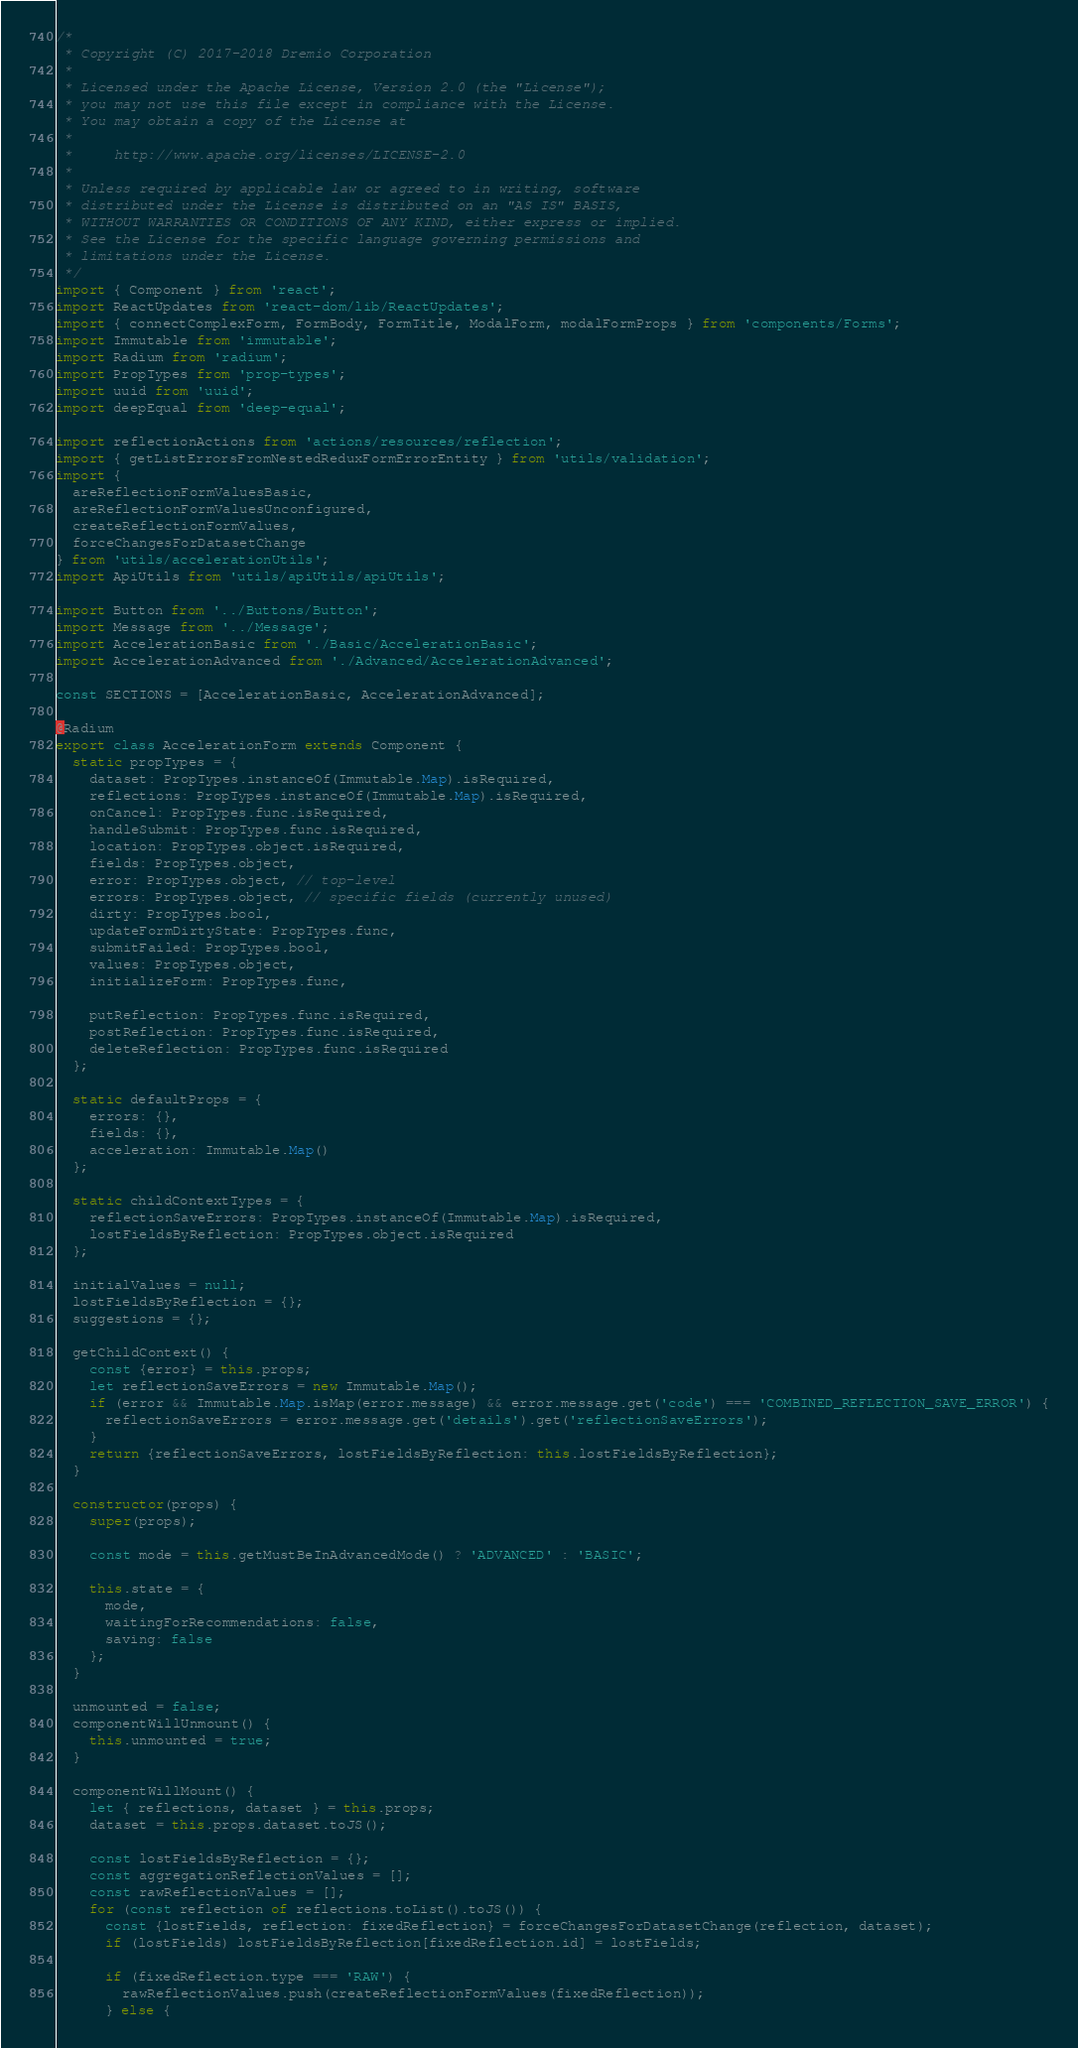Convert code to text. <code><loc_0><loc_0><loc_500><loc_500><_JavaScript_>/*
 * Copyright (C) 2017-2018 Dremio Corporation
 *
 * Licensed under the Apache License, Version 2.0 (the "License");
 * you may not use this file except in compliance with the License.
 * You may obtain a copy of the License at
 *
 *     http://www.apache.org/licenses/LICENSE-2.0
 *
 * Unless required by applicable law or agreed to in writing, software
 * distributed under the License is distributed on an "AS IS" BASIS,
 * WITHOUT WARRANTIES OR CONDITIONS OF ANY KIND, either express or implied.
 * See the License for the specific language governing permissions and
 * limitations under the License.
 */
import { Component } from 'react';
import ReactUpdates from 'react-dom/lib/ReactUpdates';
import { connectComplexForm, FormBody, FormTitle, ModalForm, modalFormProps } from 'components/Forms';
import Immutable from 'immutable';
import Radium from 'radium';
import PropTypes from 'prop-types';
import uuid from 'uuid';
import deepEqual from 'deep-equal';

import reflectionActions from 'actions/resources/reflection';
import { getListErrorsFromNestedReduxFormErrorEntity } from 'utils/validation';
import {
  areReflectionFormValuesBasic,
  areReflectionFormValuesUnconfigured,
  createReflectionFormValues,
  forceChangesForDatasetChange
} from 'utils/accelerationUtils';
import ApiUtils from 'utils/apiUtils/apiUtils';

import Button from '../Buttons/Button';
import Message from '../Message';
import AccelerationBasic from './Basic/AccelerationBasic';
import AccelerationAdvanced from './Advanced/AccelerationAdvanced';

const SECTIONS = [AccelerationBasic, AccelerationAdvanced];

@Radium
export class AccelerationForm extends Component {
  static propTypes = {
    dataset: PropTypes.instanceOf(Immutable.Map).isRequired,
    reflections: PropTypes.instanceOf(Immutable.Map).isRequired,
    onCancel: PropTypes.func.isRequired,
    handleSubmit: PropTypes.func.isRequired,
    location: PropTypes.object.isRequired,
    fields: PropTypes.object,
    error: PropTypes.object, // top-level
    errors: PropTypes.object, // specific fields (currently unused)
    dirty: PropTypes.bool,
    updateFormDirtyState: PropTypes.func,
    submitFailed: PropTypes.bool,
    values: PropTypes.object,
    initializeForm: PropTypes.func,

    putReflection: PropTypes.func.isRequired,
    postReflection: PropTypes.func.isRequired,
    deleteReflection: PropTypes.func.isRequired
  };

  static defaultProps = {
    errors: {},
    fields: {},
    acceleration: Immutable.Map()
  };

  static childContextTypes = {
    reflectionSaveErrors: PropTypes.instanceOf(Immutable.Map).isRequired,
    lostFieldsByReflection: PropTypes.object.isRequired
  };

  initialValues = null;
  lostFieldsByReflection = {};
  suggestions = {};

  getChildContext() {
    const {error} = this.props;
    let reflectionSaveErrors = new Immutable.Map();
    if (error && Immutable.Map.isMap(error.message) && error.message.get('code') === 'COMBINED_REFLECTION_SAVE_ERROR') {
      reflectionSaveErrors = error.message.get('details').get('reflectionSaveErrors');
    }
    return {reflectionSaveErrors, lostFieldsByReflection: this.lostFieldsByReflection};
  }

  constructor(props) {
    super(props);

    const mode = this.getMustBeInAdvancedMode() ? 'ADVANCED' : 'BASIC';

    this.state = {
      mode,
      waitingForRecommendations: false,
      saving: false
    };
  }

  unmounted = false;
  componentWillUnmount() {
    this.unmounted = true;
  }

  componentWillMount() {
    let { reflections, dataset } = this.props;
    dataset = this.props.dataset.toJS();

    const lostFieldsByReflection = {};
    const aggregationReflectionValues = [];
    const rawReflectionValues = [];
    for (const reflection of reflections.toList().toJS()) {
      const {lostFields, reflection: fixedReflection} = forceChangesForDatasetChange(reflection, dataset);
      if (lostFields) lostFieldsByReflection[fixedReflection.id] = lostFields;

      if (fixedReflection.type === 'RAW') {
        rawReflectionValues.push(createReflectionFormValues(fixedReflection));
      } else {</code> 